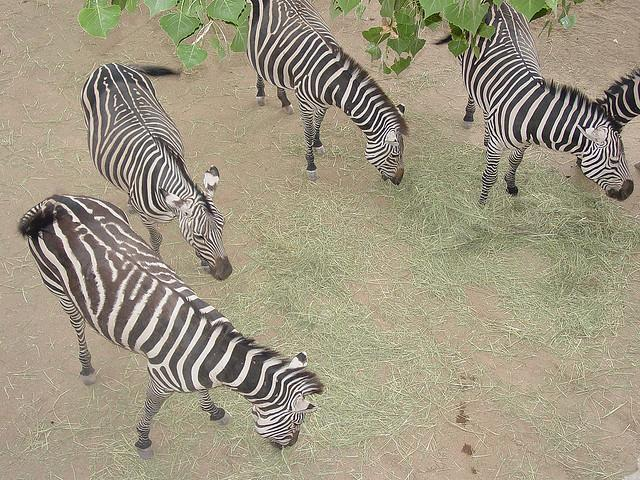How many zebras are standing on the hay below the tree? five 